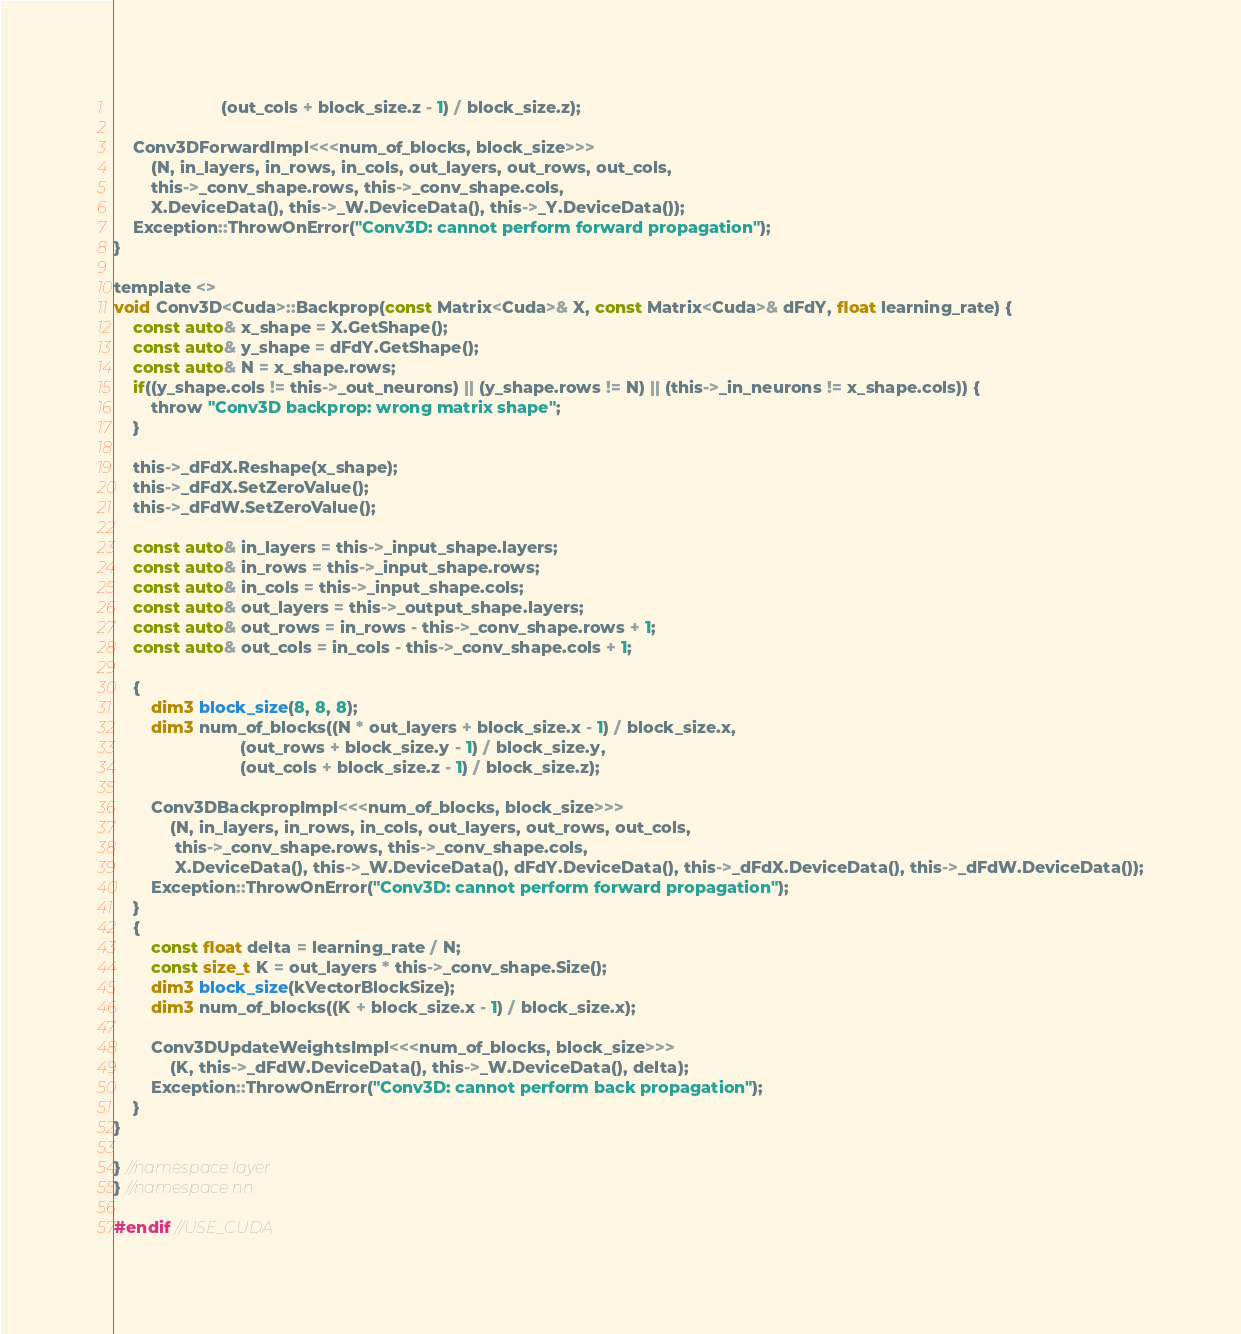<code> <loc_0><loc_0><loc_500><loc_500><_Cuda_>                       (out_cols + block_size.z - 1) / block_size.z);

    Conv3DForwardImpl<<<num_of_blocks, block_size>>>
        (N, in_layers, in_rows, in_cols, out_layers, out_rows, out_cols,
        this->_conv_shape.rows, this->_conv_shape.cols,
        X.DeviceData(), this->_W.DeviceData(), this->_Y.DeviceData());
    Exception::ThrowOnError("Conv3D: cannot perform forward propagation");
}

template <>
void Conv3D<Cuda>::Backprop(const Matrix<Cuda>& X, const Matrix<Cuda>& dFdY, float learning_rate) {
    const auto& x_shape = X.GetShape();
    const auto& y_shape = dFdY.GetShape();
    const auto& N = x_shape.rows;
    if((y_shape.cols != this->_out_neurons) || (y_shape.rows != N) || (this->_in_neurons != x_shape.cols)) {
        throw "Conv3D backprop: wrong matrix shape";
    }

    this->_dFdX.Reshape(x_shape);
    this->_dFdX.SetZeroValue();
    this->_dFdW.SetZeroValue();

    const auto& in_layers = this->_input_shape.layers;
    const auto& in_rows = this->_input_shape.rows;
    const auto& in_cols = this->_input_shape.cols;
    const auto& out_layers = this->_output_shape.layers;
    const auto& out_rows = in_rows - this->_conv_shape.rows + 1;
    const auto& out_cols = in_cols - this->_conv_shape.cols + 1;

    {
        dim3 block_size(8, 8, 8);
        dim3 num_of_blocks((N * out_layers + block_size.x - 1) / block_size.x,
                           (out_rows + block_size.y - 1) / block_size.y,
                           (out_cols + block_size.z - 1) / block_size.z);

        Conv3DBackpropImpl<<<num_of_blocks, block_size>>>
            (N, in_layers, in_rows, in_cols, out_layers, out_rows, out_cols,
             this->_conv_shape.rows, this->_conv_shape.cols,
             X.DeviceData(), this->_W.DeviceData(), dFdY.DeviceData(), this->_dFdX.DeviceData(), this->_dFdW.DeviceData());
        Exception::ThrowOnError("Conv3D: cannot perform forward propagation");
    }
    {
        const float delta = learning_rate / N;
        const size_t K = out_layers * this->_conv_shape.Size();
        dim3 block_size(kVectorBlockSize);
        dim3 num_of_blocks((K + block_size.x - 1) / block_size.x);

        Conv3DUpdateWeightsImpl<<<num_of_blocks, block_size>>>
            (K, this->_dFdW.DeviceData(), this->_W.DeviceData(), delta);
        Exception::ThrowOnError("Conv3D: cannot perform back propagation");
    }
}

} //namespace layer
} //namespace nn

#endif //USE_CUDA
</code> 